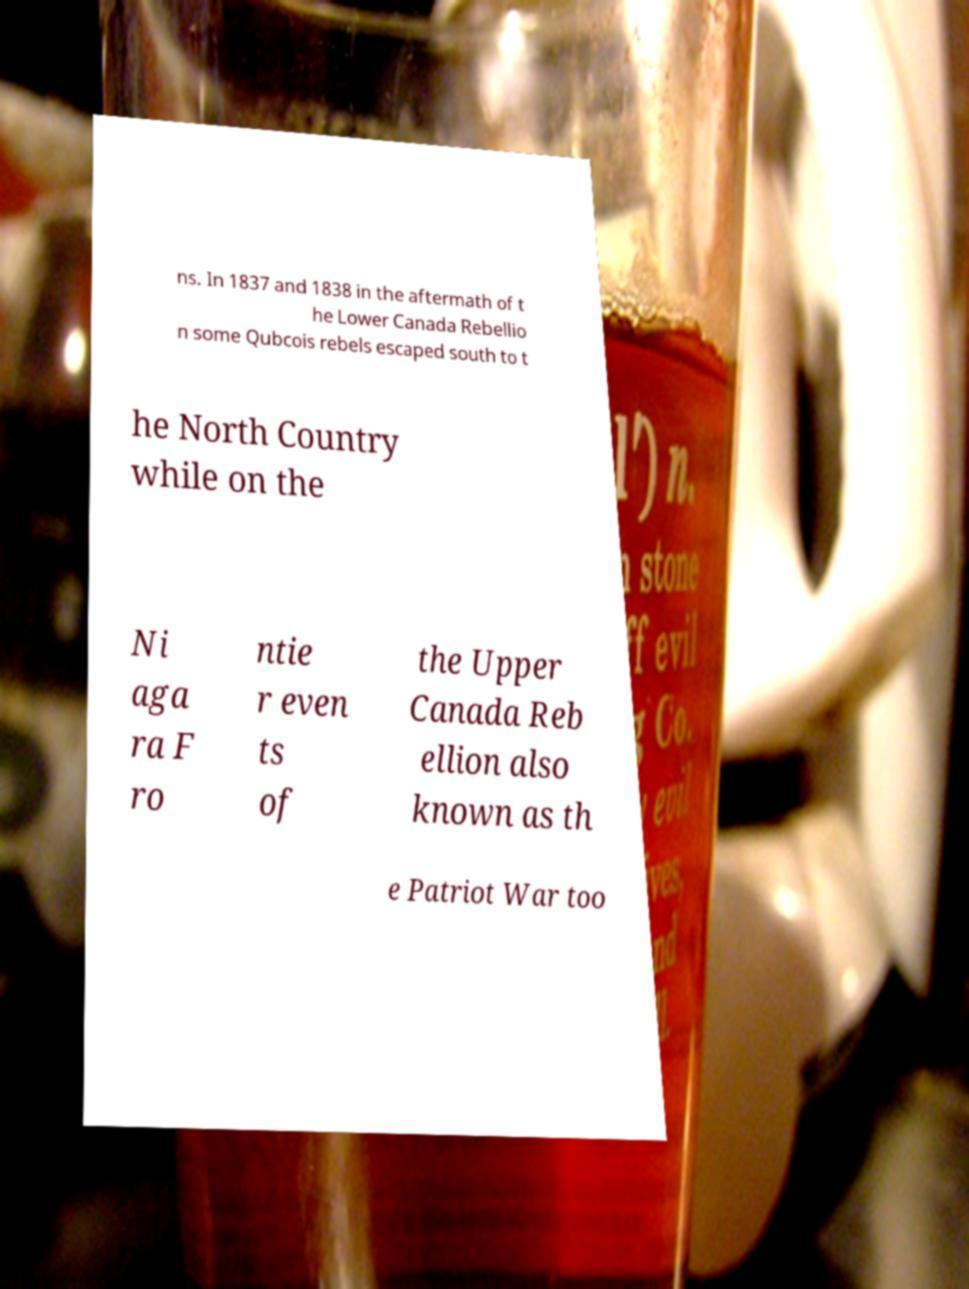Could you assist in decoding the text presented in this image and type it out clearly? ns. In 1837 and 1838 in the aftermath of t he Lower Canada Rebellio n some Qubcois rebels escaped south to t he North Country while on the Ni aga ra F ro ntie r even ts of the Upper Canada Reb ellion also known as th e Patriot War too 